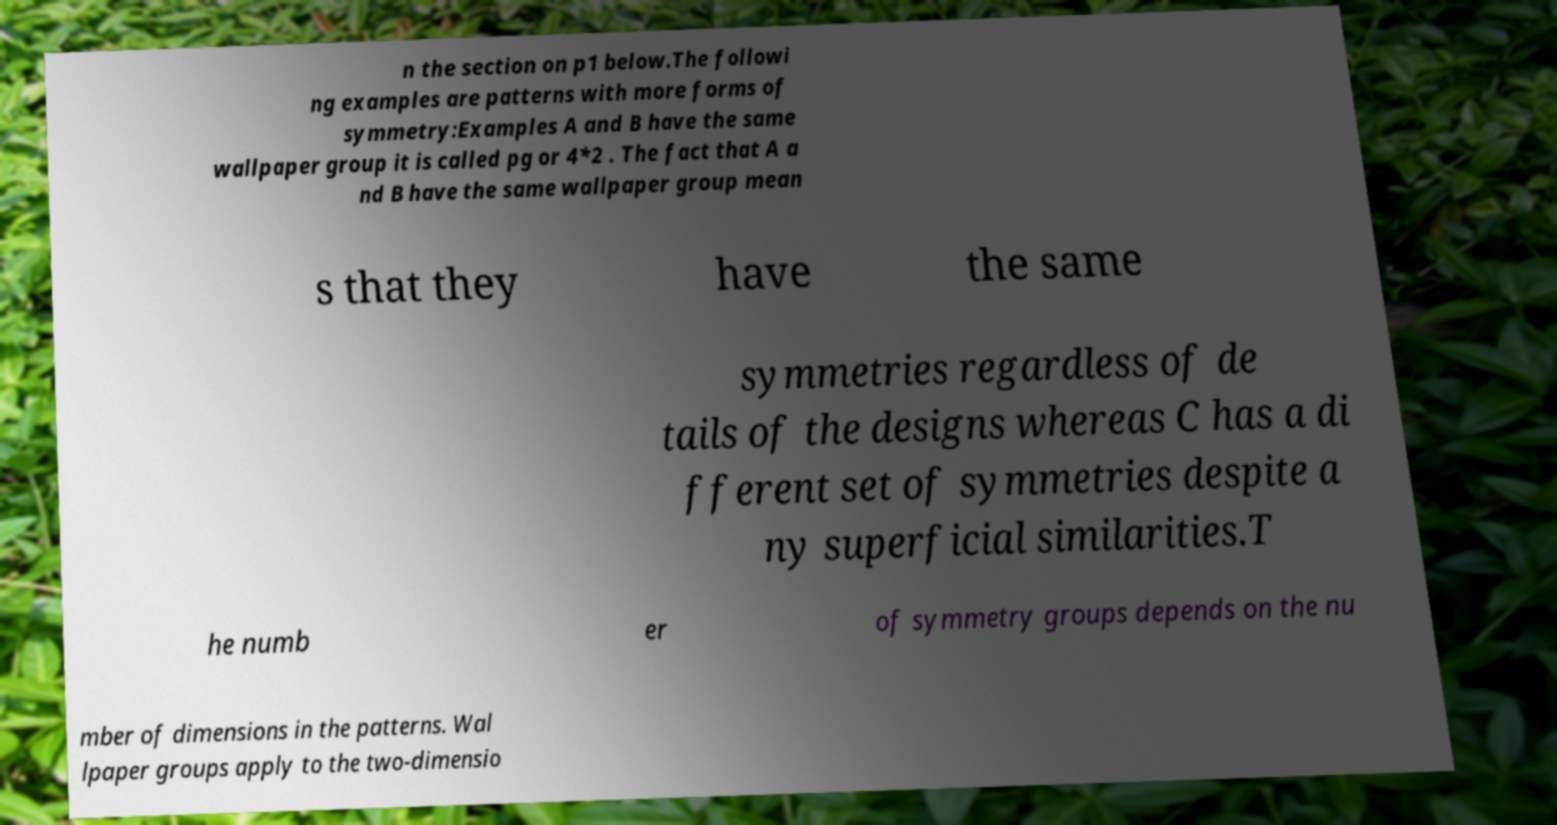There's text embedded in this image that I need extracted. Can you transcribe it verbatim? n the section on p1 below.The followi ng examples are patterns with more forms of symmetry:Examples A and B have the same wallpaper group it is called pg or 4*2 . The fact that A a nd B have the same wallpaper group mean s that they have the same symmetries regardless of de tails of the designs whereas C has a di fferent set of symmetries despite a ny superficial similarities.T he numb er of symmetry groups depends on the nu mber of dimensions in the patterns. Wal lpaper groups apply to the two-dimensio 